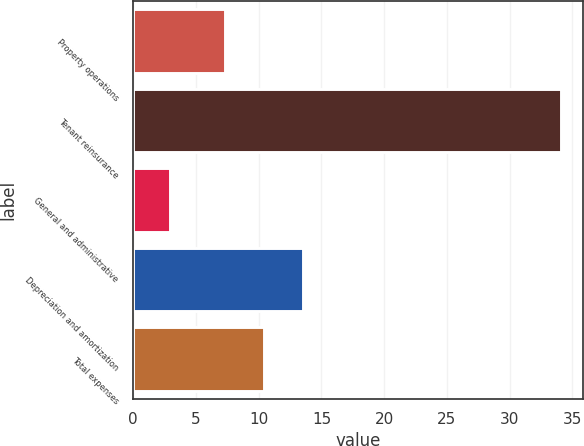Convert chart to OTSL. <chart><loc_0><loc_0><loc_500><loc_500><bar_chart><fcel>Property operations<fcel>Tenant reinsurance<fcel>General and administrative<fcel>Depreciation and amortization<fcel>Total expenses<nl><fcel>7.3<fcel>34.1<fcel>2.9<fcel>13.54<fcel>10.42<nl></chart> 